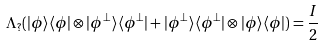Convert formula to latex. <formula><loc_0><loc_0><loc_500><loc_500>\Lambda _ { ? } ( | \phi \rangle \langle \phi | \otimes | \phi ^ { \perp } \rangle \langle \phi ^ { \perp } | + | \phi ^ { \perp } \rangle \langle \phi ^ { \perp } | \otimes | \phi \rangle \langle \phi | ) = \frac { I } { 2 }</formula> 